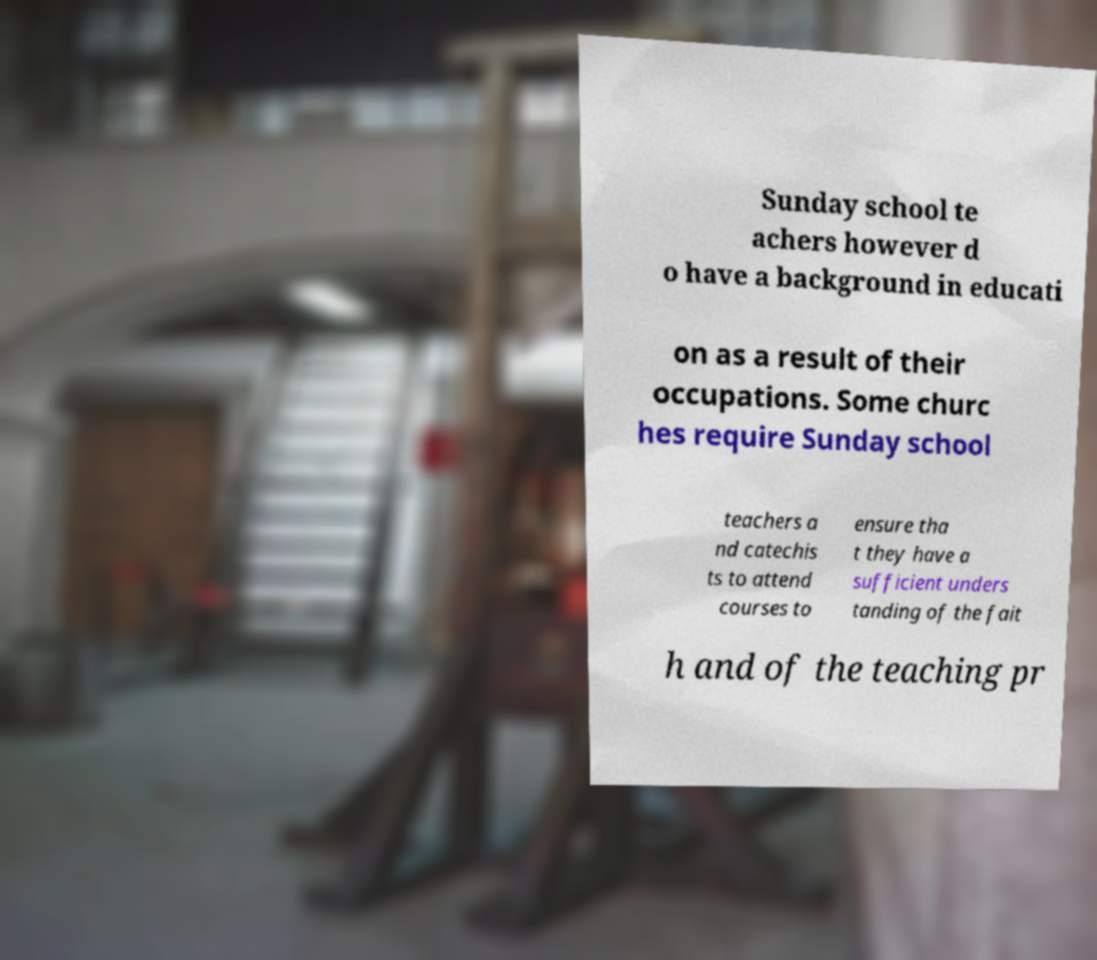For documentation purposes, I need the text within this image transcribed. Could you provide that? Sunday school te achers however d o have a background in educati on as a result of their occupations. Some churc hes require Sunday school teachers a nd catechis ts to attend courses to ensure tha t they have a sufficient unders tanding of the fait h and of the teaching pr 